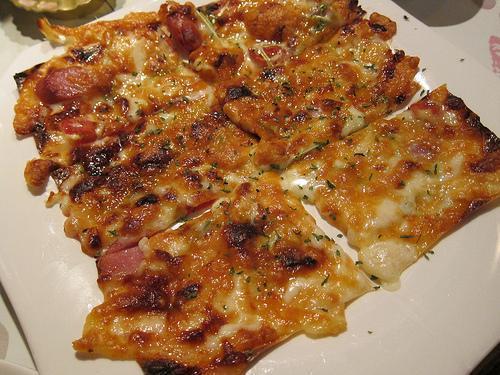How many plates are there?
Give a very brief answer. 1. How many empty plates are there?
Give a very brief answer. 0. 